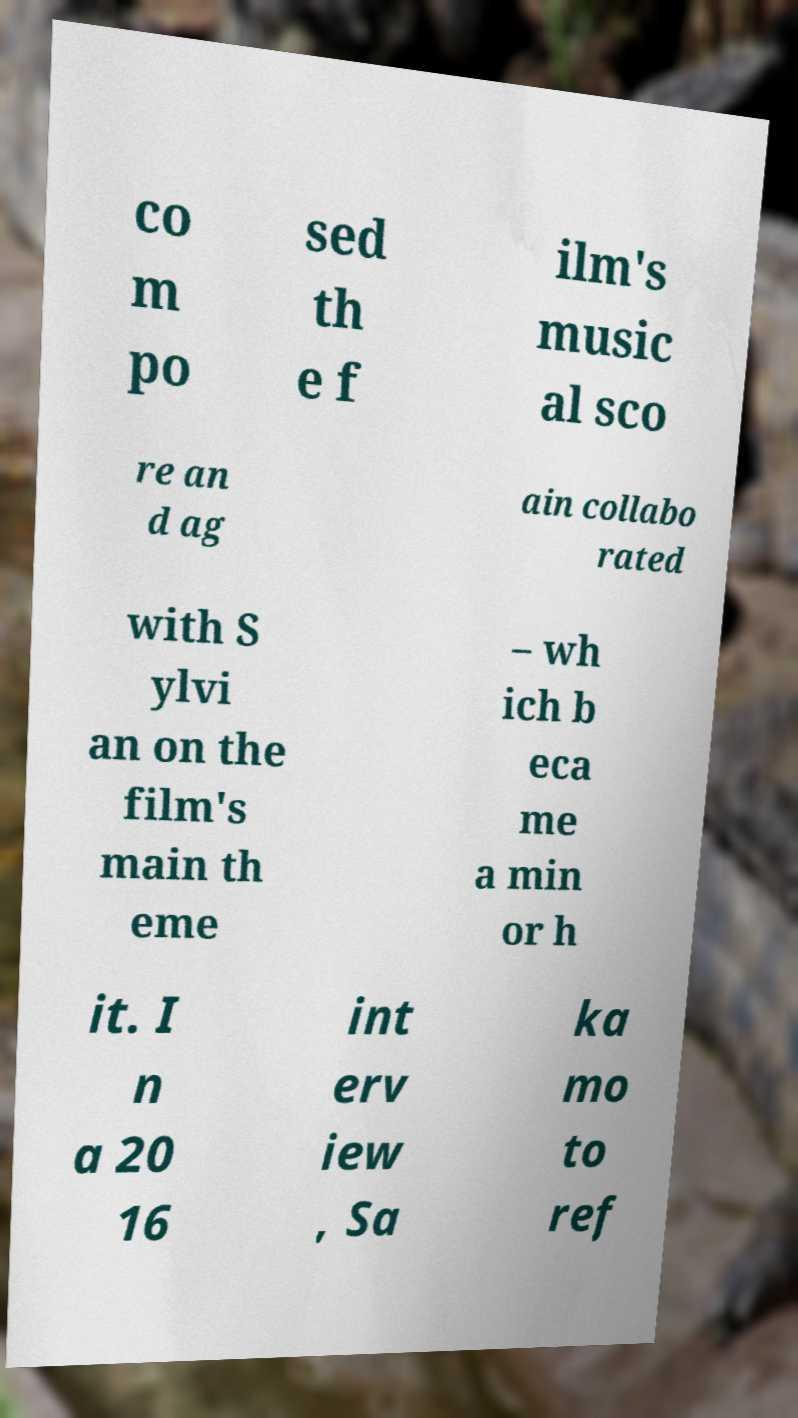There's text embedded in this image that I need extracted. Can you transcribe it verbatim? co m po sed th e f ilm's music al sco re an d ag ain collabo rated with S ylvi an on the film's main th eme – wh ich b eca me a min or h it. I n a 20 16 int erv iew , Sa ka mo to ref 